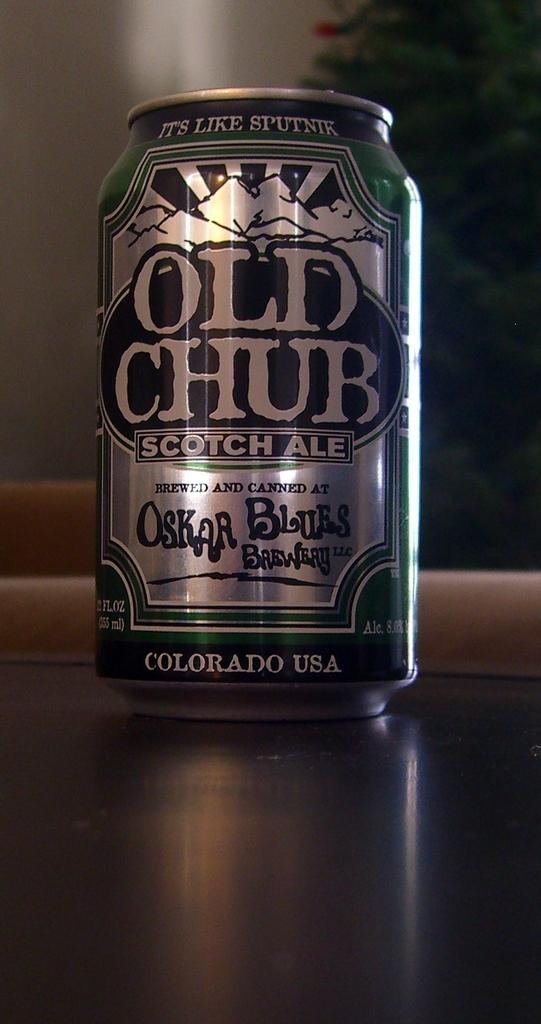<image>
Relay a brief, clear account of the picture shown. A can of Old Chub scotch ale says it comes from Colorado. 